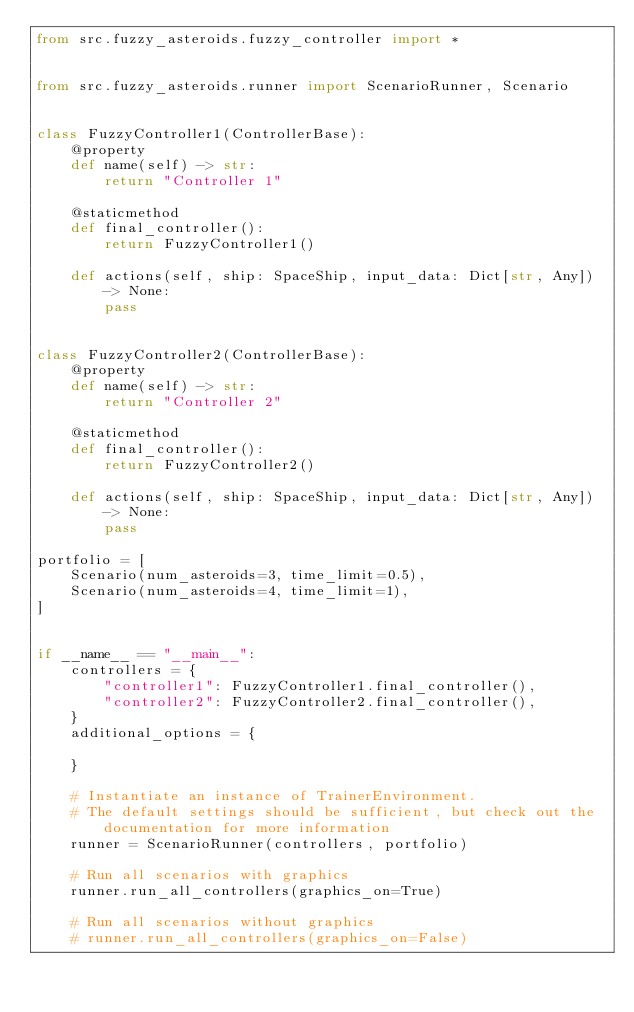Convert code to text. <code><loc_0><loc_0><loc_500><loc_500><_Python_>from src.fuzzy_asteroids.fuzzy_controller import *


from src.fuzzy_asteroids.runner import ScenarioRunner, Scenario


class FuzzyController1(ControllerBase):
    @property
    def name(self) -> str:
        return "Controller 1"

    @staticmethod
    def final_controller():
        return FuzzyController1()

    def actions(self, ship: SpaceShip, input_data: Dict[str, Any]) -> None:
        pass


class FuzzyController2(ControllerBase):
    @property
    def name(self) -> str:
        return "Controller 2"

    @staticmethod
    def final_controller():
        return FuzzyController2()

    def actions(self, ship: SpaceShip, input_data: Dict[str, Any]) -> None:
        pass

portfolio = [
    Scenario(num_asteroids=3, time_limit=0.5),
    Scenario(num_asteroids=4, time_limit=1),
]


if __name__ == "__main__":
    controllers = {
        "controller1": FuzzyController1.final_controller(),
        "controller2": FuzzyController2.final_controller(),
    }
    additional_options = {

    }

    # Instantiate an instance of TrainerEnvironment.
    # The default settings should be sufficient, but check out the documentation for more information
    runner = ScenarioRunner(controllers, portfolio)

    # Run all scenarios with graphics
    runner.run_all_controllers(graphics_on=True)

    # Run all scenarios without graphics
    # runner.run_all_controllers(graphics_on=False)
</code> 